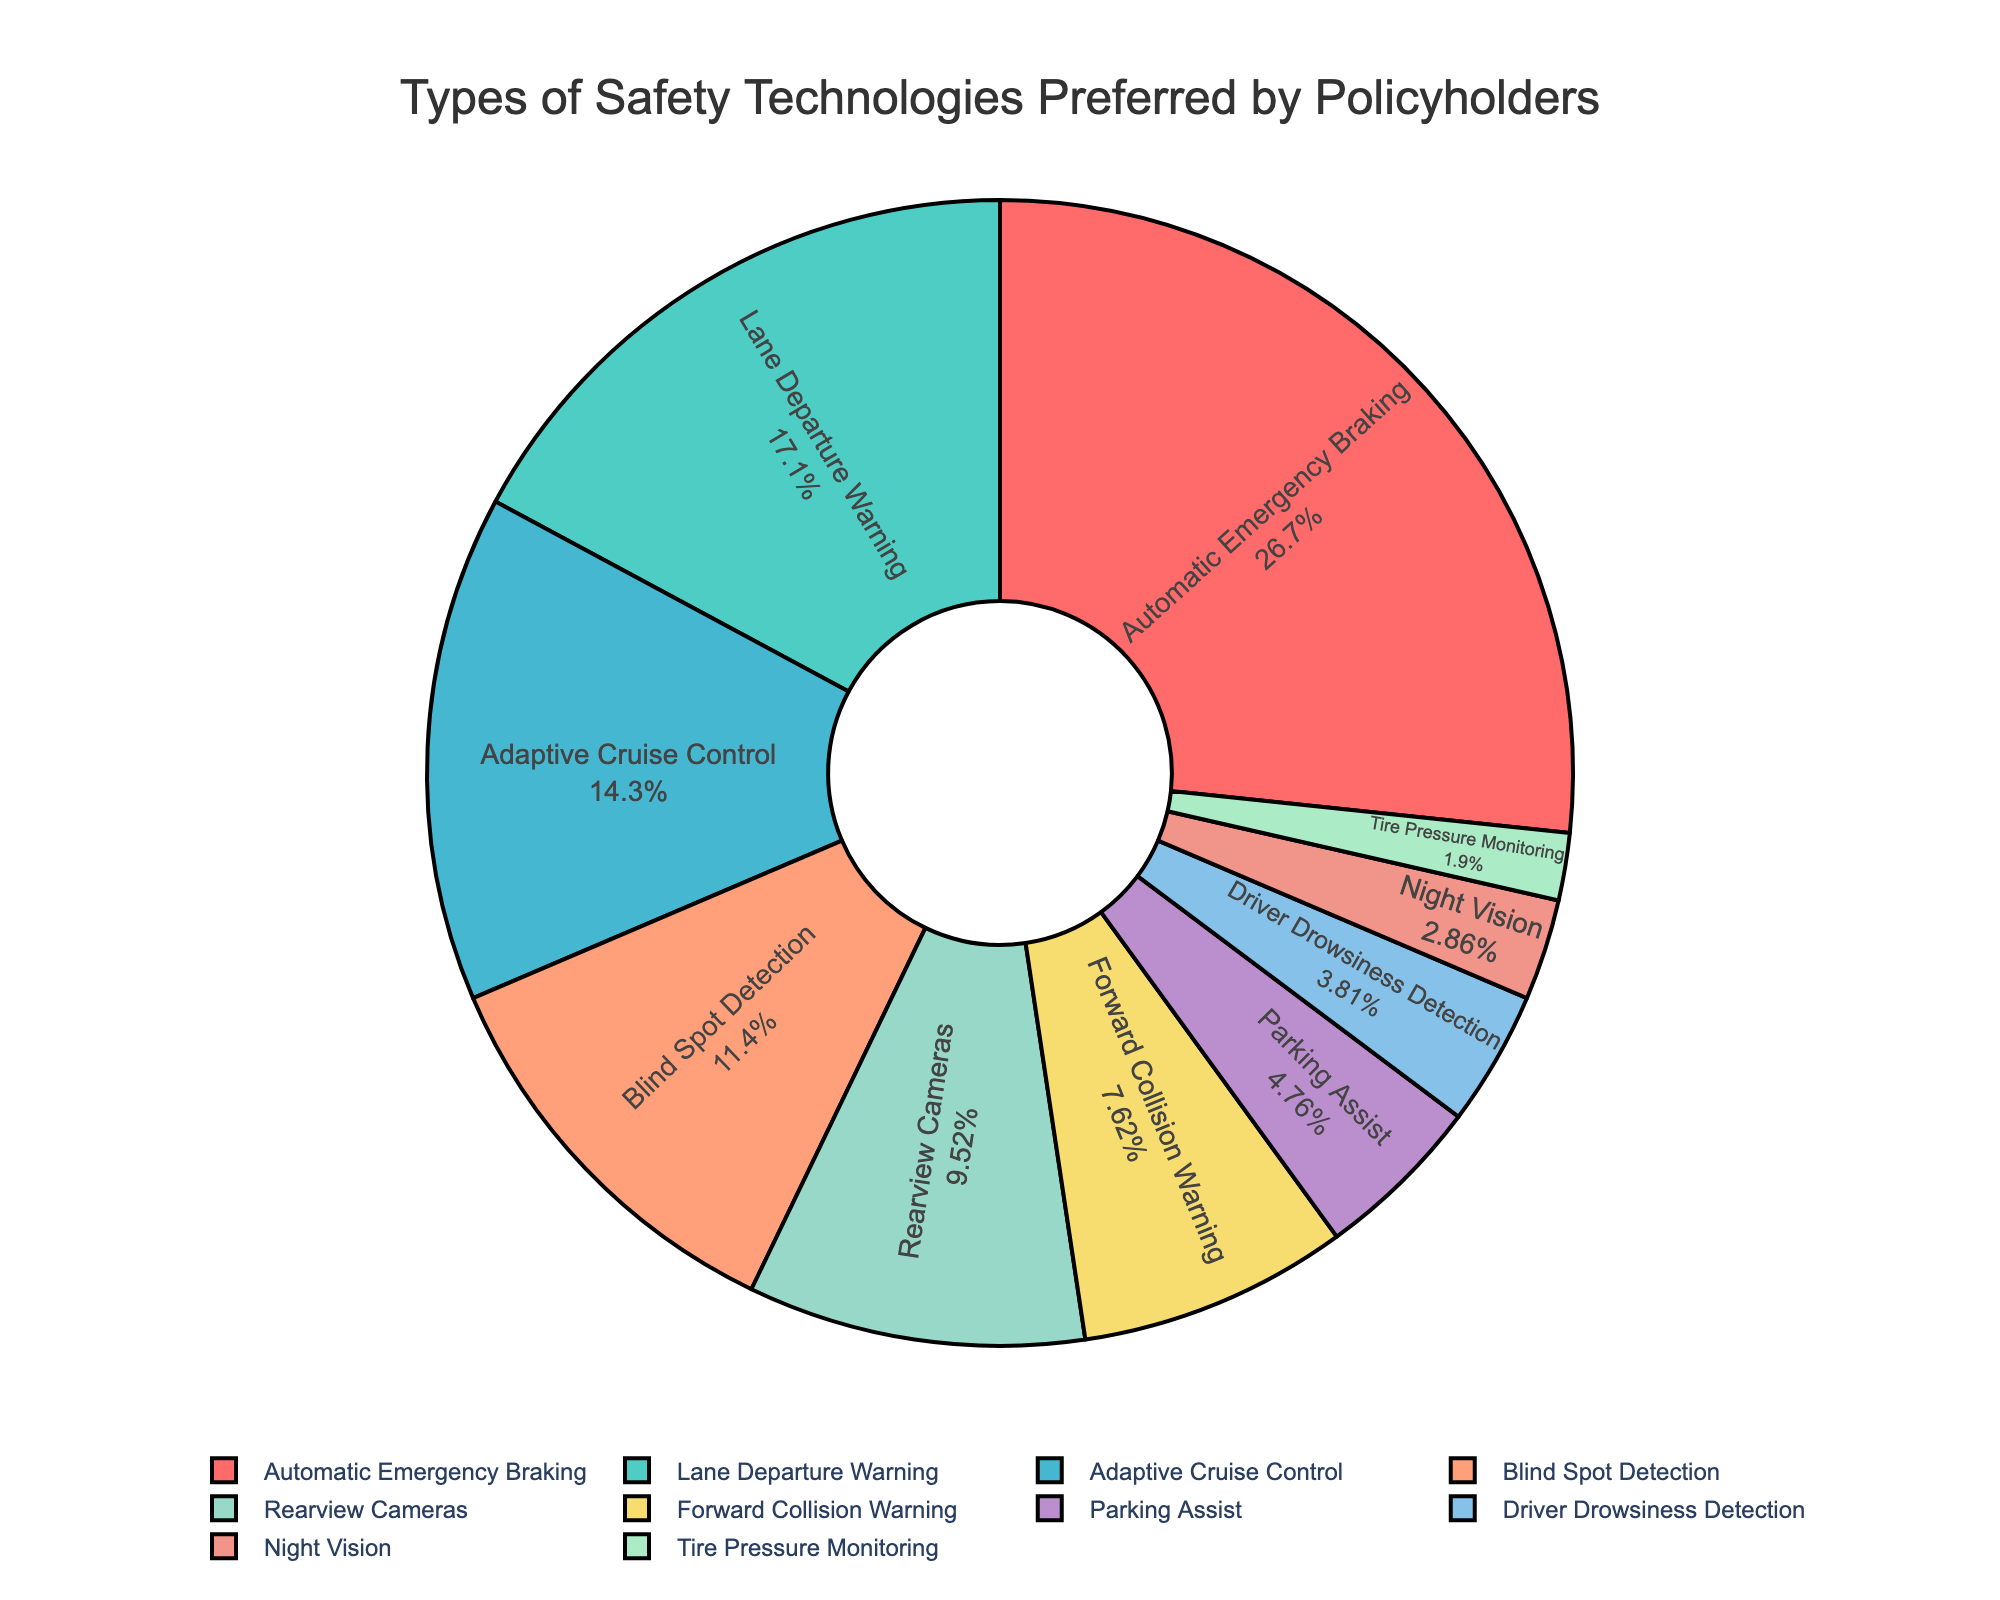What percentage of policyholders prefer Adaptive Cruise Control compared to those who prefer Lane Departure Warning? We observe that 15% of policyholders prefer Adaptive Cruise Control while 18% prefer Lane Departure Warning. The difference between these two percentages is 18% - 15% = 3%.
Answer: 3% What's the total percentage of policyholders who prefer Automatic Emergency Braking, Lane Departure Warning, and Adaptive Cruise Control combined? Automatic Emergency Braking is 28%, Lane Departure Warning is 18%, and Adaptive Cruise Control is 15%. Adding these together, we get 28% + 18% + 15% = 61%.
Answer: 61% Which safety technology is least preferred by policyholders? By looking at the pie chart, we can see that the segment corresponding to Tire Pressure Monitoring is the smallest, representing 2%.
Answer: Tire Pressure Monitoring How much more popular is Blind Spot Detection compared to Forward Collision Warning? The pie chart indicates that Blind Spot Detection has 12% preference and Forward Collision Warning has 8%. The difference is 12% - 8% = 4%.
Answer: 4% What's the combined percentage of policyholders who prefer technologies designed to prevent collisions (Automatic Emergency Braking, Forward Collision Warning, and Blind Spot Detection)? Automatic Emergency Braking has 28%, Forward Collision Warning has 8%, and Blind Spot Detection has 12%. Adding these gives 28% + 8% + 12% = 48%.
Answer: 48% Which colors represent Rearview Cameras and Driver Drowsiness Detection, and what are their percentages? The pie chart shows Rearview Cameras in a light green color corresponding to 10%, and Driver Drowsiness Detection in a light blue color corresponding to 4%.
Answer: Rearview Cameras: light green (10%), Driver Drowsiness Detection: light blue (4%) Is the percentage of policyholders who prefer Parking Assist higher or lower than those who prefer Blind Spot Detection, and by how much? Parking Assist is preferred by 5% of policyholders, while Blind Spot Detection is preferred by 12%. The difference is 12% - 5% = 7%, indicating that Parking Assist is less preferred.
Answer: Lower by 7% How much more popular is Automatic Emergency Braking than the least preferred technology? Automatic Emergency Braking is preferred by 28% of policyholders, while the least preferred technology, Tire Pressure Monitoring, is preferred by 2%. The difference is 28% - 2% = 26%.
Answer: 26% What is the total percentage of policyholders who prefer safety technologies related to driver assistance (Adaptive Cruise Control, Lane Departure Warning, Driver Drowsiness Detection, and Parking Assist)? Adaptive Cruise Control is 15%, Lane Departure Warning is 18%, Driver Drowsiness Detection is 4%, and Parking Assist is 5%. Summing these preferences totals 15% + 18% + 4% + 5% = 42%.
Answer: 42% What technology is preferred by 3% of policyholders and what is its visual representation in the pie chart? Night Vision is preferred by 3% of policyholders and is represented by a yellow segment in the pie chart.
Answer: Night Vision: yellow (3%) 